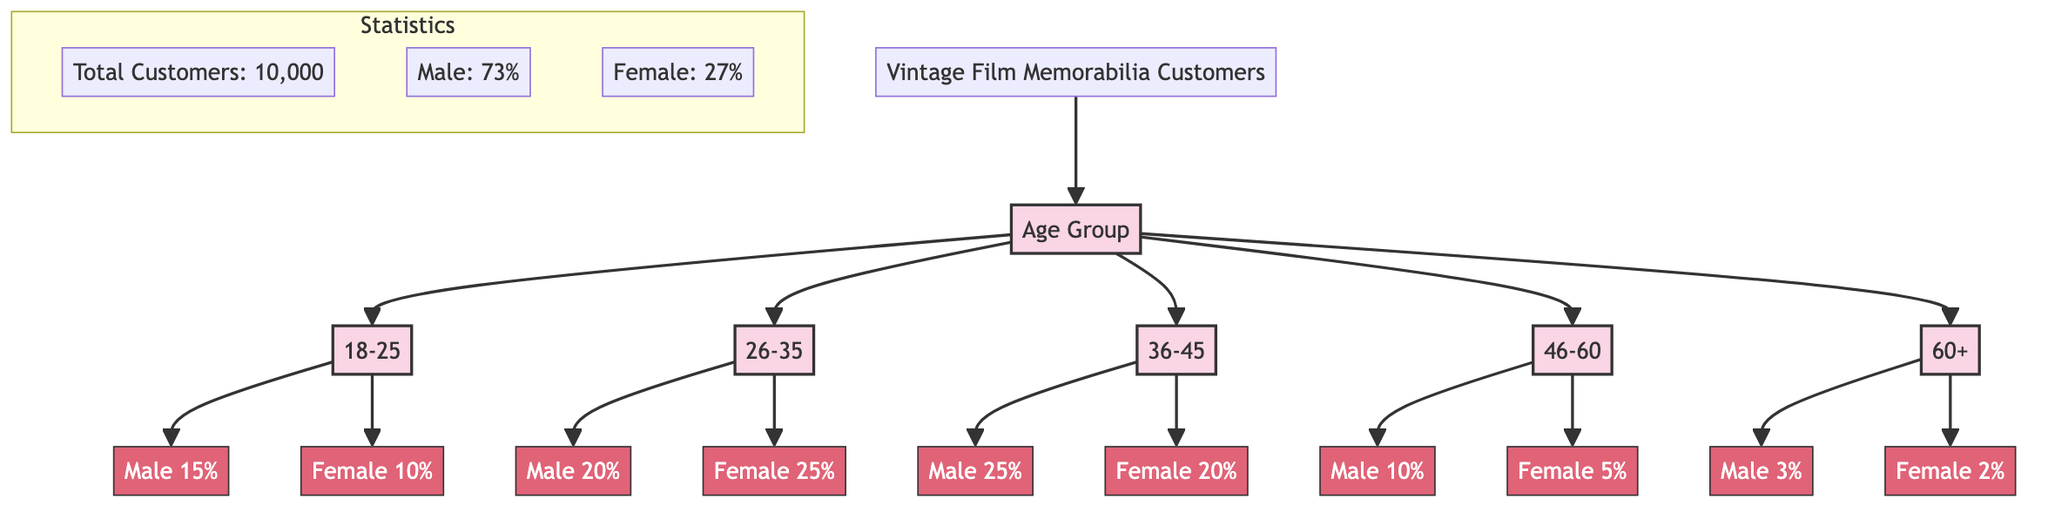What is the female percentage in the 26-35 age group? The diagram shows that in the age group 26-35, the female percentage is represented as 25%. This can be found directly on the diagram under the node linked to the age group.
Answer: 25% Which age group has the highest percentage of male customers? By examining the diagram, the age group 36-45 is linked to 25% male customers, which is the highest percentage across all age groups when compared to the others.
Answer: 36-45 What is the total percentage of male customers across all age groups? The diagram states that the total number of male customers is 73%. This percentage represents the overall male demographic within the vintage film memorabilia customer base.
Answer: 73% How many age groups are represented in the diagram? The diagram clearly shows five distinct age groups connected to the main customer node, which can be counted as 18-25, 26-35, 36-45, 46-60, and 60+.
Answer: 5 In the age group 60+, what is the male customer percentage? The diagram indicates that the male percentage in the 60+ age group is 3%, which can be directly observed in the corresponding node of the diagram.
Answer: 3% 